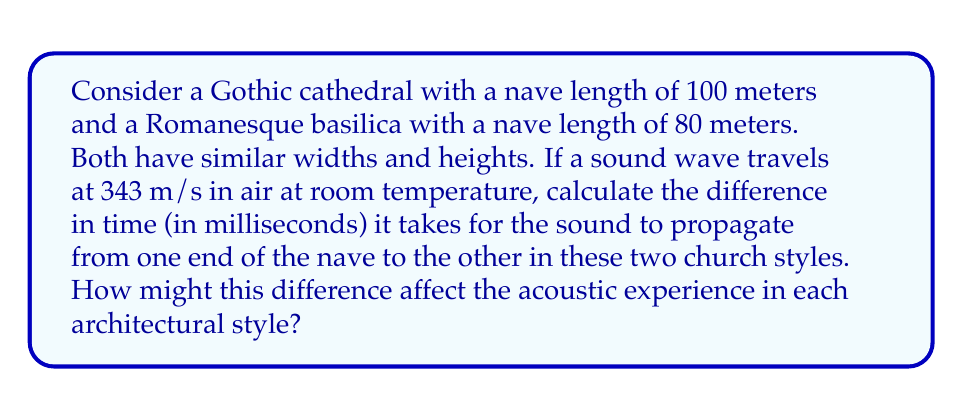Help me with this question. To solve this problem, we'll use the wave equation in its simplest form:

$$ v = \frac{d}{t} $$

Where:
$v$ is the velocity of the wave (343 m/s)
$d$ is the distance traveled (length of the nave)
$t$ is the time taken

Step 1: Calculate the time for sound to travel in the Gothic cathedral
$$ t_{Gothic} = \frac{d_{Gothic}}{v} = \frac{100 \text{ m}}{343 \text{ m/s}} \approx 0.2915 \text{ s} $$

Step 2: Calculate the time for sound to travel in the Romanesque basilica
$$ t_{Romanesque} = \frac{d_{Romanesque}}{v} = \frac{80 \text{ m}}{343 \text{ m/s}} \approx 0.2332 \text{ s} $$

Step 3: Calculate the difference in time
$$ \Delta t = t_{Gothic} - t_{Romanesque} \approx 0.2915 \text{ s} - 0.2332 \text{ s} = 0.0583 \text{ s} $$

Step 4: Convert the time difference to milliseconds
$$ \Delta t_{ms} = 0.0583 \text{ s} \times 1000 \text{ ms/s} = 58.3 \text{ ms} $$

The difference in propagation time affects the acoustic experience in each architectural style:

1. Reverberation: The longer nave in the Gothic cathedral results in a longer reverberation time, creating a more ethereal and enveloping sound.

2. Clarity: The shorter nave in the Romanesque basilica may provide clearer sound with less echo, potentially improving speech intelligibility.

3. Musical performance: The Gothic cathedral's longer reverberation time may be more suitable for certain types of music (e.g., Gregorian chants), while the Romanesque basilica might be better for more rhythmic or faster-paced music.

4. Spatial perception: The difference in propagation time contributes to the perceived size and grandeur of the space, with the Gothic cathedral feeling larger and more awe-inspiring.
Answer: 58.3 ms 